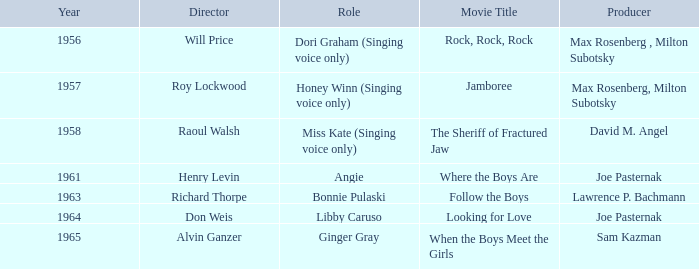What year was Sam Kazman a producer? 1965.0. 